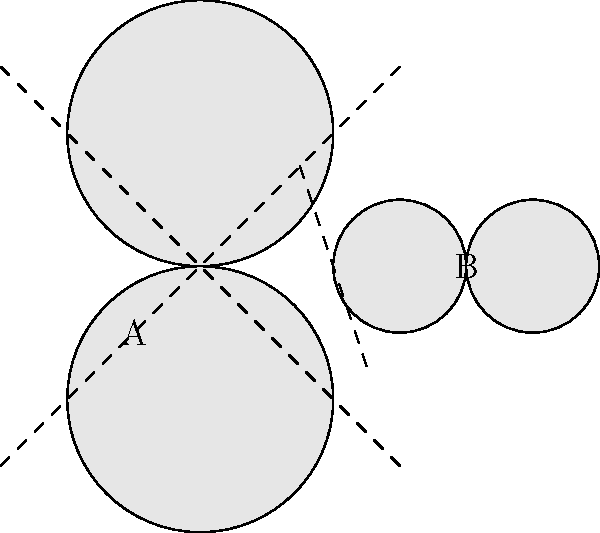Observe the mollusk shell patterns labeled A and B. Which type of symmetry is present in each pattern? To determine the symmetry in each mollusk shell pattern, we need to analyze the arrangement and reflections of the shapes:

1. Pattern A:
   - The shape is reflected across both diagonal lines.
   - It remains unchanged when rotated 180 degrees.
   - This indicates both rotational symmetry of order 2 and reflectional symmetry across two axes.

2. Pattern B:
   - The shape is reflected across a vertical line.
   - It remains unchanged when flipped horizontally.
   - This indicates reflectional symmetry across one axis.

In mathematical terms:
- Pattern A exhibits $D_2$ symmetry (dihedral group of order 2), also known as bilateral symmetry.
- Pattern B exhibits $D_1$ symmetry, which is simple reflectional symmetry.

As a marine biology student studying mollusks, recognizing these symmetry patterns is crucial for understanding shell morphology and species identification.
Answer: A: $D_2$ symmetry; B: $D_1$ symmetry 